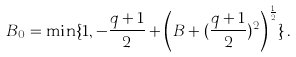<formula> <loc_0><loc_0><loc_500><loc_500>B _ { 0 } = \min \{ 1 , - \frac { q + 1 } 2 + \left ( B + ( \frac { q + 1 } 2 ) ^ { 2 } \right ) ^ { \frac { 1 } { 2 } } \} \, .</formula> 